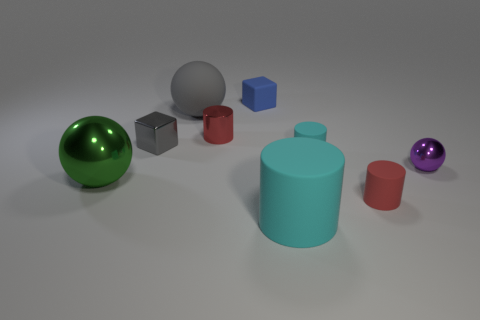Subtract all red shiny cylinders. How many cylinders are left? 3 Subtract all red spheres. How many cyan cylinders are left? 2 Subtract all red cylinders. How many cylinders are left? 2 Subtract 2 cylinders. How many cylinders are left? 2 Subtract 0 yellow spheres. How many objects are left? 9 Subtract all balls. How many objects are left? 6 Subtract all brown cylinders. Subtract all green balls. How many cylinders are left? 4 Subtract all small cyan objects. Subtract all cubes. How many objects are left? 6 Add 5 small cubes. How many small cubes are left? 7 Add 7 big cyan blocks. How many big cyan blocks exist? 7 